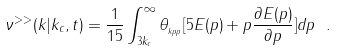Convert formula to latex. <formula><loc_0><loc_0><loc_500><loc_500>\nu ^ { > > } ( k | k _ { c } , t ) = \frac { 1 } { 1 5 } \int _ { 3 k _ { c } } ^ { \infty } \theta _ { _ { k p p } } [ 5 E ( p ) + p \frac { \partial E ( p ) } { \partial p } ] d p \ .</formula> 